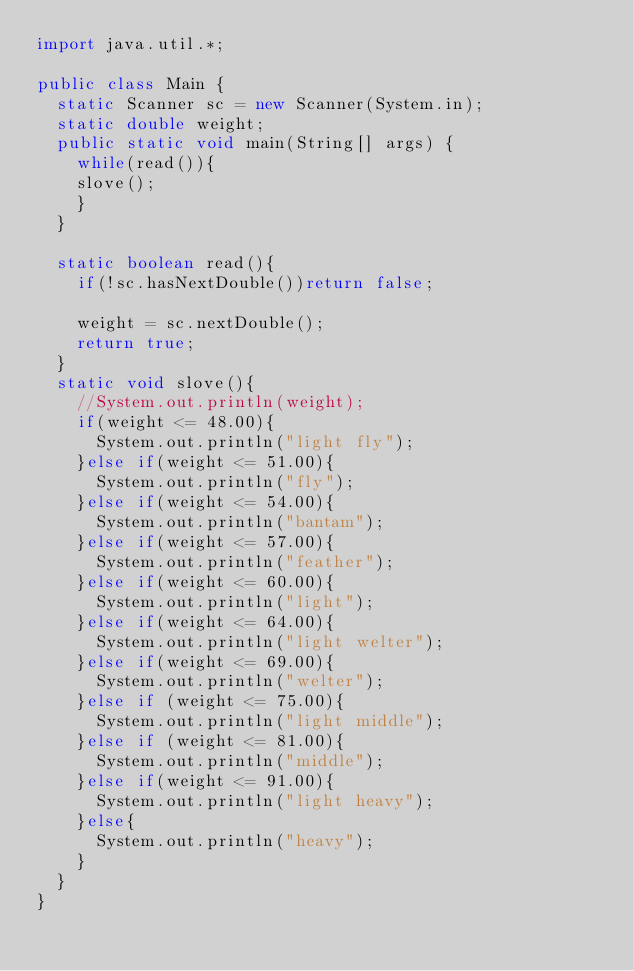Convert code to text. <code><loc_0><loc_0><loc_500><loc_500><_Java_>import java.util.*;

public class Main {
	static Scanner sc = new Scanner(System.in);
	static double weight;
	public static void main(String[] args) {
		while(read()){
		slove();
		}
	}

	static boolean read(){
		if(!sc.hasNextDouble())return false;
		
		weight = sc.nextDouble();
		return true;
	}
	static void slove(){
		//System.out.println(weight);
		if(weight <= 48.00){
			System.out.println("light fly");
		}else if(weight <= 51.00){
			System.out.println("fly");
		}else if(weight <= 54.00){
			System.out.println("bantam");
		}else if(weight <= 57.00){
			System.out.println("feather");
		}else if(weight <= 60.00){
			System.out.println("light");
		}else if(weight <= 64.00){
			System.out.println("light welter");
		}else if(weight <= 69.00){
			System.out.println("welter");
		}else if (weight <= 75.00){
			System.out.println("light middle");
		}else if (weight <= 81.00){
			System.out.println("middle");
		}else if(weight <= 91.00){
			System.out.println("light heavy");
		}else{
			System.out.println("heavy");
		}
	}
}</code> 